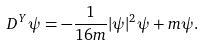Convert formula to latex. <formula><loc_0><loc_0><loc_500><loc_500>D ^ { Y } \psi = - \frac { 1 } { 1 6 m } | \psi | ^ { 2 } \psi + m \psi .</formula> 